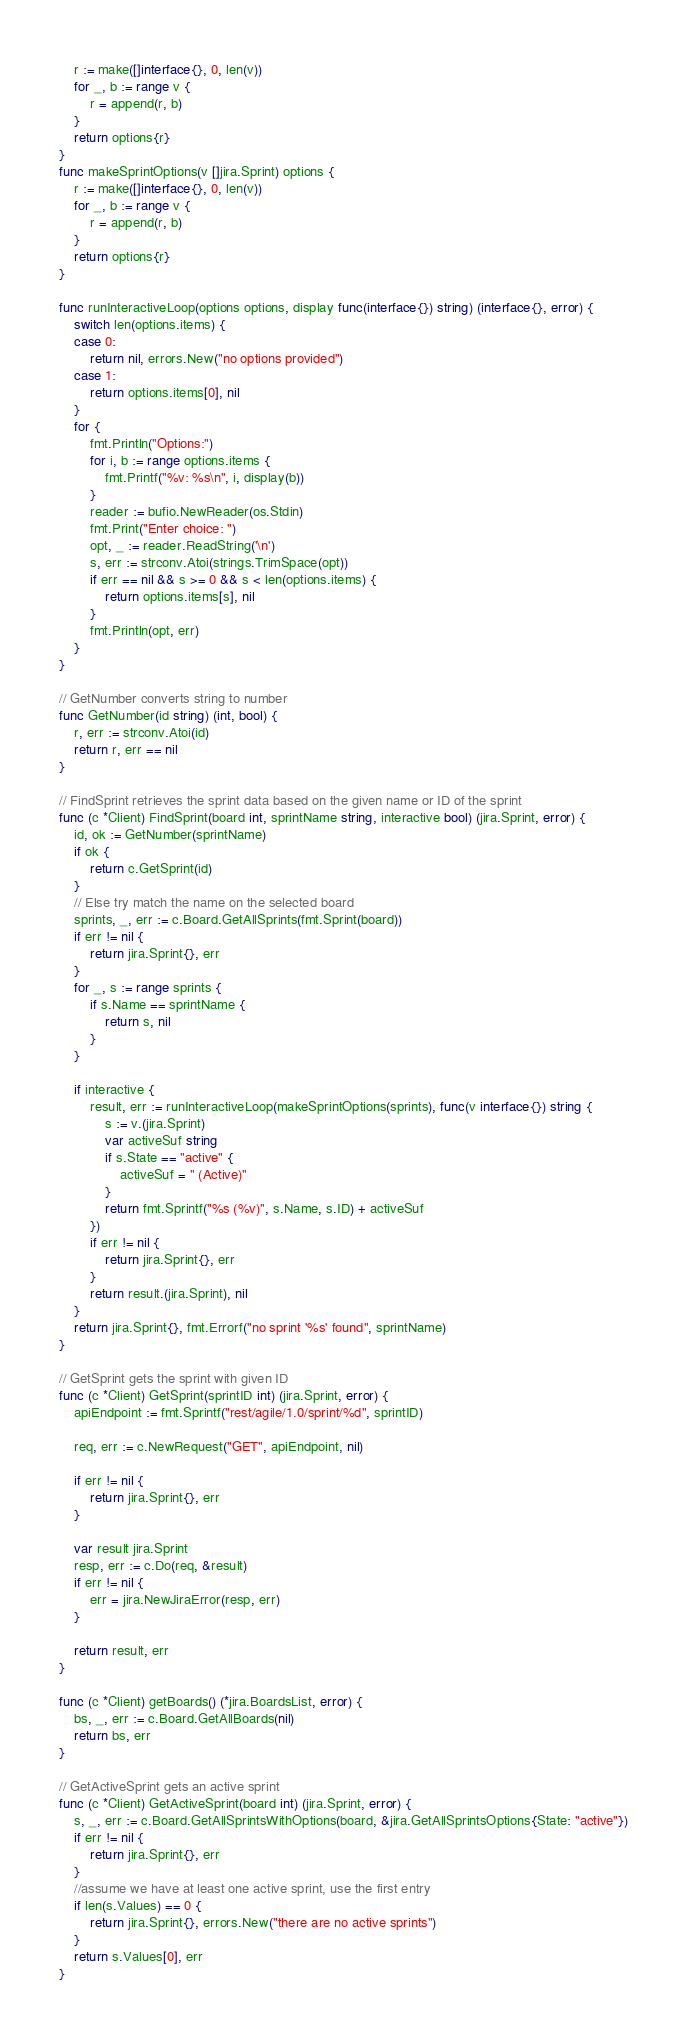Convert code to text. <code><loc_0><loc_0><loc_500><loc_500><_Go_>	r := make([]interface{}, 0, len(v))
	for _, b := range v {
		r = append(r, b)
	}
	return options{r}
}
func makeSprintOptions(v []jira.Sprint) options {
	r := make([]interface{}, 0, len(v))
	for _, b := range v {
		r = append(r, b)
	}
	return options{r}
}

func runInteractiveLoop(options options, display func(interface{}) string) (interface{}, error) {
	switch len(options.items) {
	case 0:
		return nil, errors.New("no options provided")
	case 1:
		return options.items[0], nil
	}
	for {
		fmt.Println("Options:")
		for i, b := range options.items {
			fmt.Printf("%v: %s\n", i, display(b))
		}
		reader := bufio.NewReader(os.Stdin)
		fmt.Print("Enter choice: ")
		opt, _ := reader.ReadString('\n')
		s, err := strconv.Atoi(strings.TrimSpace(opt))
		if err == nil && s >= 0 && s < len(options.items) {
			return options.items[s], nil
		}
		fmt.Println(opt, err)
	}
}

// GetNumber converts string to number
func GetNumber(id string) (int, bool) {
	r, err := strconv.Atoi(id)
	return r, err == nil
}

// FindSprint retrieves the sprint data based on the given name or ID of the sprint
func (c *Client) FindSprint(board int, sprintName string, interactive bool) (jira.Sprint, error) {
	id, ok := GetNumber(sprintName)
	if ok {
		return c.GetSprint(id)
	}
	// Else try match the name on the selected board
	sprints, _, err := c.Board.GetAllSprints(fmt.Sprint(board))
	if err != nil {
		return jira.Sprint{}, err
	}
	for _, s := range sprints {
		if s.Name == sprintName {
			return s, nil
		}
	}

	if interactive {
		result, err := runInteractiveLoop(makeSprintOptions(sprints), func(v interface{}) string {
			s := v.(jira.Sprint)
			var activeSuf string
			if s.State == "active" {
				activeSuf = " (Active)"
			}
			return fmt.Sprintf("%s (%v)", s.Name, s.ID) + activeSuf
		})
		if err != nil {
			return jira.Sprint{}, err
		}
		return result.(jira.Sprint), nil
	}
	return jira.Sprint{}, fmt.Errorf("no sprint '%s' found", sprintName)
}

// GetSprint gets the sprint with given ID
func (c *Client) GetSprint(sprintID int) (jira.Sprint, error) {
	apiEndpoint := fmt.Sprintf("rest/agile/1.0/sprint/%d", sprintID)

	req, err := c.NewRequest("GET", apiEndpoint, nil)

	if err != nil {
		return jira.Sprint{}, err
	}

	var result jira.Sprint
	resp, err := c.Do(req, &result)
	if err != nil {
		err = jira.NewJiraError(resp, err)
	}

	return result, err
}

func (c *Client) getBoards() (*jira.BoardsList, error) {
	bs, _, err := c.Board.GetAllBoards(nil)
	return bs, err
}

// GetActiveSprint gets an active sprint
func (c *Client) GetActiveSprint(board int) (jira.Sprint, error) {
	s, _, err := c.Board.GetAllSprintsWithOptions(board, &jira.GetAllSprintsOptions{State: "active"})
	if err != nil {
		return jira.Sprint{}, err
	}
	//assume we have at least one active sprint, use the first entry
	if len(s.Values) == 0 {
		return jira.Sprint{}, errors.New("there are no active sprints")
	}
	return s.Values[0], err
}
</code> 